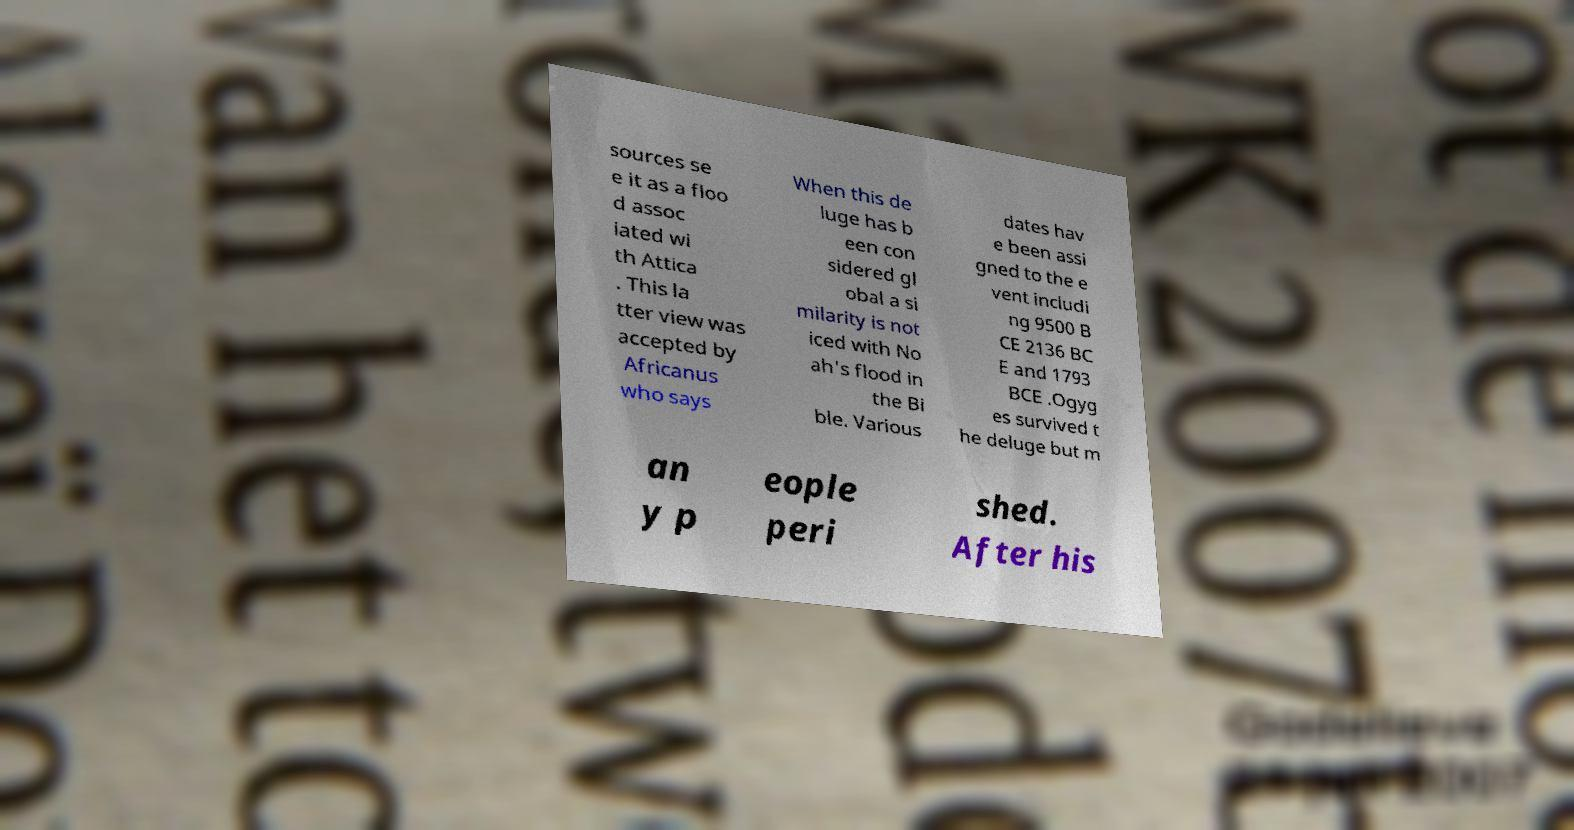Can you read and provide the text displayed in the image?This photo seems to have some interesting text. Can you extract and type it out for me? sources se e it as a floo d assoc iated wi th Attica . This la tter view was accepted by Africanus who says When this de luge has b een con sidered gl obal a si milarity is not iced with No ah's flood in the Bi ble. Various dates hav e been assi gned to the e vent includi ng 9500 B CE 2136 BC E and 1793 BCE .Ogyg es survived t he deluge but m an y p eople peri shed. After his 